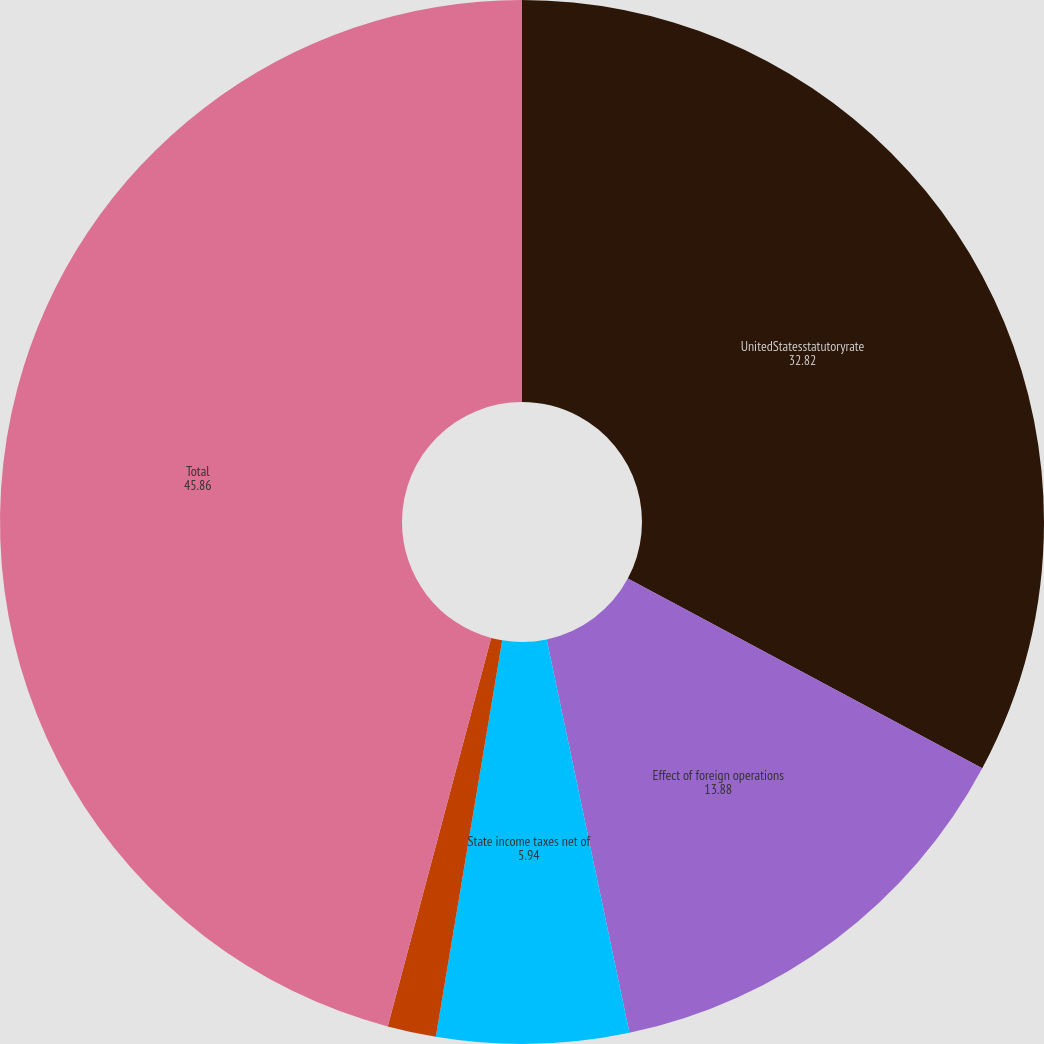Convert chart. <chart><loc_0><loc_0><loc_500><loc_500><pie_chart><fcel>UnitedStatesstatutoryrate<fcel>Effect of foreign operations<fcel>State income taxes net of<fcel>Other<fcel>Total<nl><fcel>32.82%<fcel>13.88%<fcel>5.94%<fcel>1.5%<fcel>45.86%<nl></chart> 